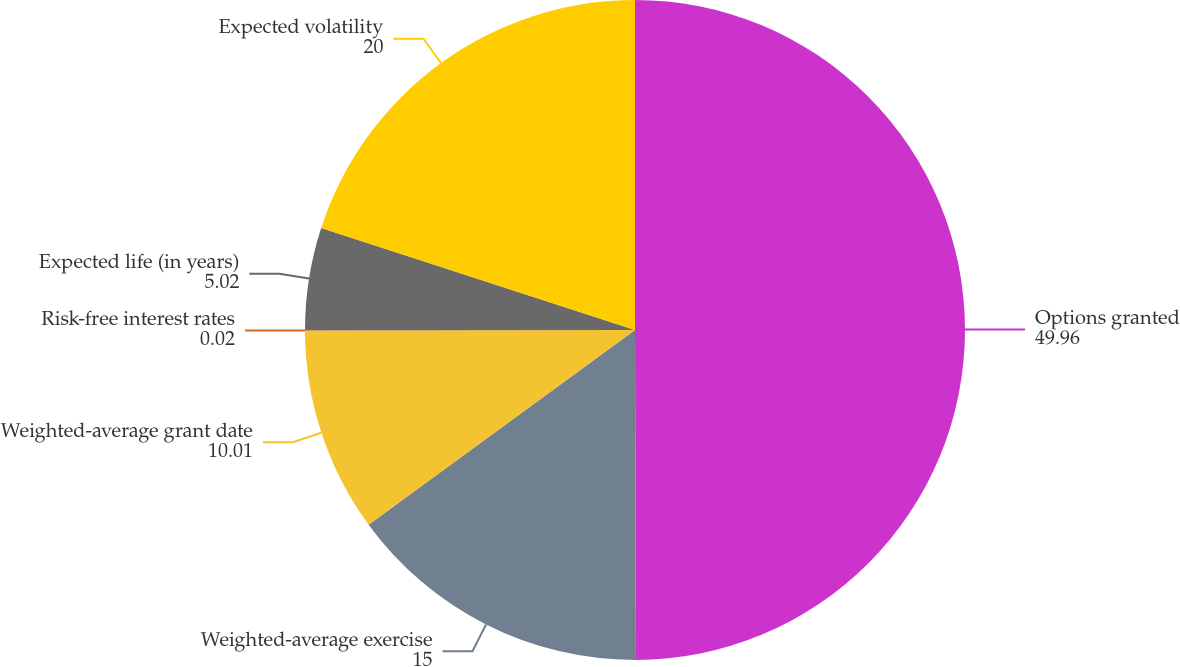Convert chart. <chart><loc_0><loc_0><loc_500><loc_500><pie_chart><fcel>Options granted<fcel>Weighted-average exercise<fcel>Weighted-average grant date<fcel>Risk-free interest rates<fcel>Expected life (in years)<fcel>Expected volatility<nl><fcel>49.96%<fcel>15.0%<fcel>10.01%<fcel>0.02%<fcel>5.02%<fcel>20.0%<nl></chart> 